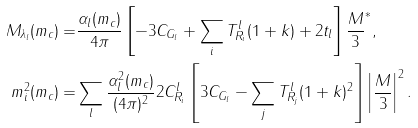<formula> <loc_0><loc_0><loc_500><loc_500>M _ { \lambda _ { l } } ( m _ { c } ) = & \frac { \alpha _ { l } ( m _ { c } ) } { 4 \pi } \left [ - 3 C _ { G _ { l } } + \sum _ { i } T ^ { l } _ { R _ { i } } ( 1 + k ) + 2 t _ { l } \right ] \frac { M } { 3 } ^ { * } , \\ m ^ { 2 } _ { i } ( m _ { c } ) = & \sum _ { l } \frac { \alpha _ { l } ^ { 2 } ( m _ { c } ) } { ( 4 \pi ) ^ { 2 } } 2 C ^ { l } _ { R _ { i } } \left [ 3 C _ { G _ { l } } - \sum _ { j } T ^ { l } _ { R _ { j } } ( 1 + k ) ^ { 2 } \right ] \left | \frac { M } { 3 } \right | ^ { 2 } .</formula> 